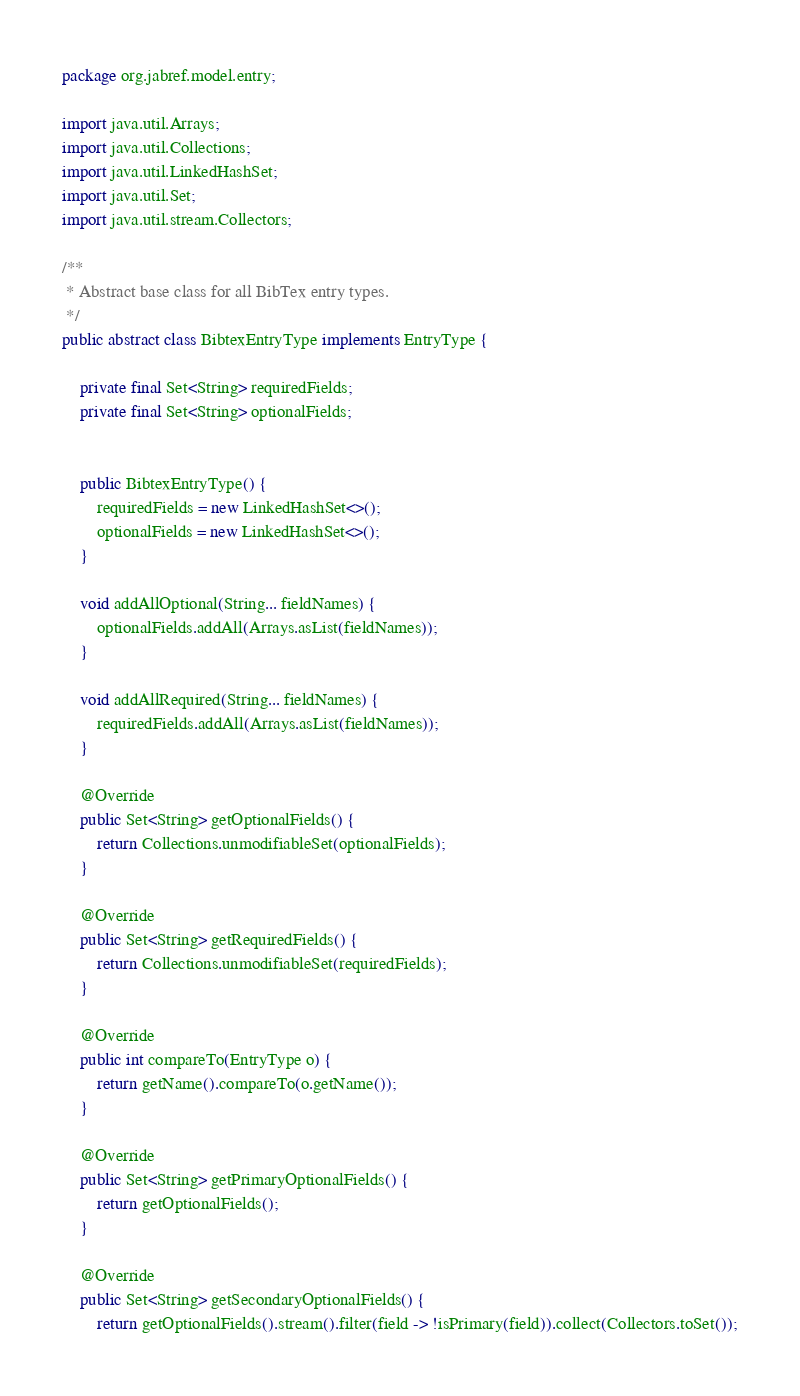<code> <loc_0><loc_0><loc_500><loc_500><_Java_>package org.jabref.model.entry;

import java.util.Arrays;
import java.util.Collections;
import java.util.LinkedHashSet;
import java.util.Set;
import java.util.stream.Collectors;

/**
 * Abstract base class for all BibTex entry types.
 */
public abstract class BibtexEntryType implements EntryType {

    private final Set<String> requiredFields;
    private final Set<String> optionalFields;


    public BibtexEntryType() {
        requiredFields = new LinkedHashSet<>();
        optionalFields = new LinkedHashSet<>();
    }

    void addAllOptional(String... fieldNames) {
        optionalFields.addAll(Arrays.asList(fieldNames));
    }

    void addAllRequired(String... fieldNames) {
        requiredFields.addAll(Arrays.asList(fieldNames));
    }

    @Override
    public Set<String> getOptionalFields() {
        return Collections.unmodifiableSet(optionalFields);
    }

    @Override
    public Set<String> getRequiredFields() {
        return Collections.unmodifiableSet(requiredFields);
    }

    @Override
    public int compareTo(EntryType o) {
        return getName().compareTo(o.getName());
    }

    @Override
    public Set<String> getPrimaryOptionalFields() {
        return getOptionalFields();
    }

    @Override
    public Set<String> getSecondaryOptionalFields() {
        return getOptionalFields().stream().filter(field -> !isPrimary(field)).collect(Collectors.toSet());</code> 